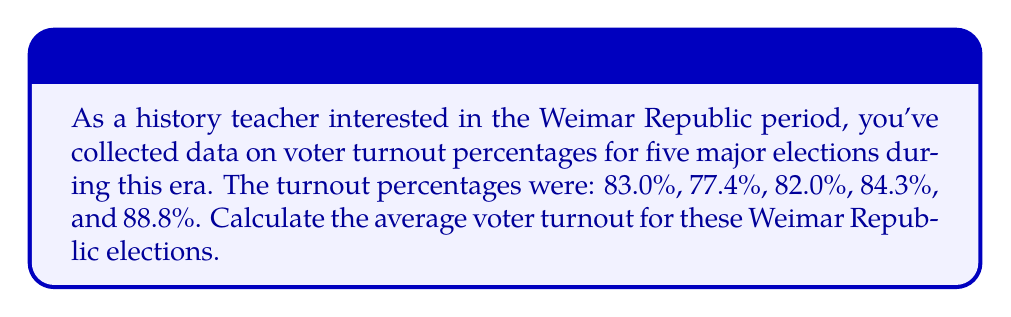Can you solve this math problem? To calculate the average voter turnout, we need to sum up all the percentages and divide by the number of elections. Let's approach this step-by-step:

1. List the given voter turnout percentages:
   $83.0\%, 77.4\%, 82.0\%, 84.3\%, 88.8\%$

2. Sum up all the percentages:
   $$83.0 + 77.4 + 82.0 + 84.3 + 88.8 = 415.5$$

3. Count the number of elections: 5

4. Calculate the average by dividing the sum by the number of elections:
   $$\text{Average} = \frac{\text{Sum of percentages}}{\text{Number of elections}} = \frac{415.5}{5} = 83.1\%$$

Thus, the average voter turnout for these Weimar Republic elections was 83.1%.
Answer: $83.1\%$ 